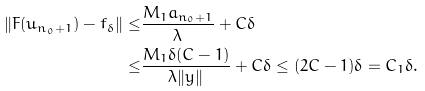<formula> <loc_0><loc_0><loc_500><loc_500>\| F ( u _ { n _ { 0 } + 1 } ) - f _ { \delta } \| \leq & \frac { M _ { 1 } a _ { n _ { 0 } + 1 } } { \lambda } + C \delta \\ \leq & \frac { M _ { 1 } \delta ( C - 1 ) } { \lambda \| y \| } + C \delta \leq ( 2 C - 1 ) \delta = C _ { 1 } \delta .</formula> 